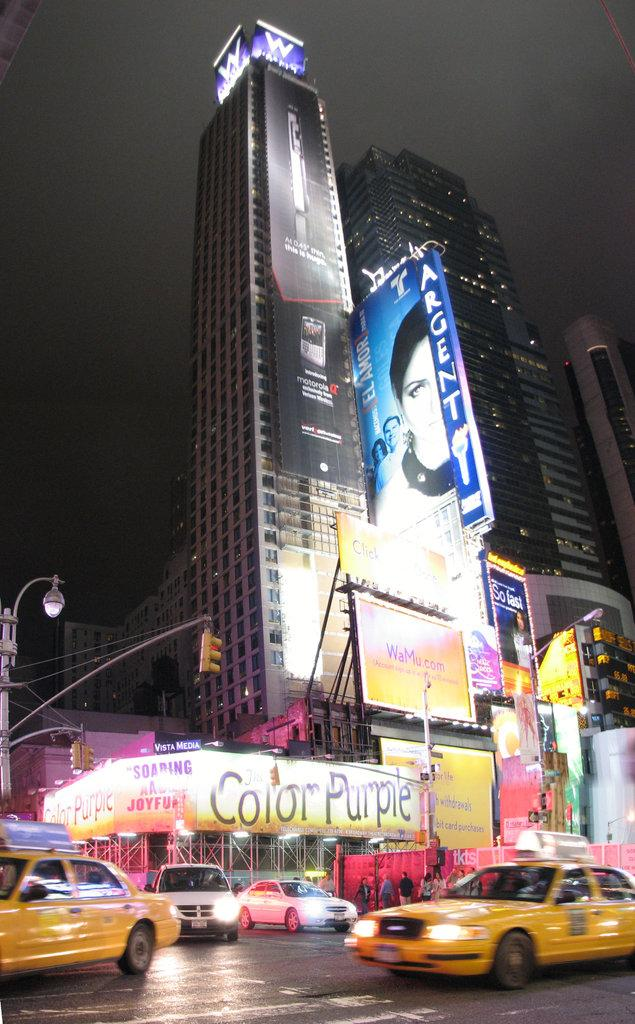<image>
Create a compact narrative representing the image presented. A busy downtown intersection at night has taxis driving past a building that says Color Purple. 